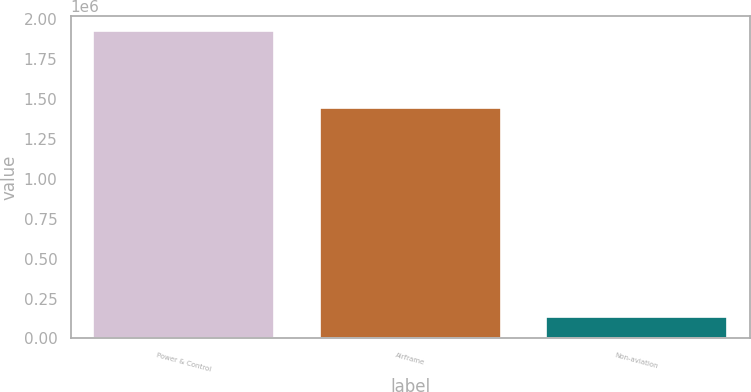<chart> <loc_0><loc_0><loc_500><loc_500><bar_chart><fcel>Power & Control<fcel>Airframe<fcel>Non-aviation<nl><fcel>1.92724e+06<fcel>1.44207e+06<fcel>134969<nl></chart> 